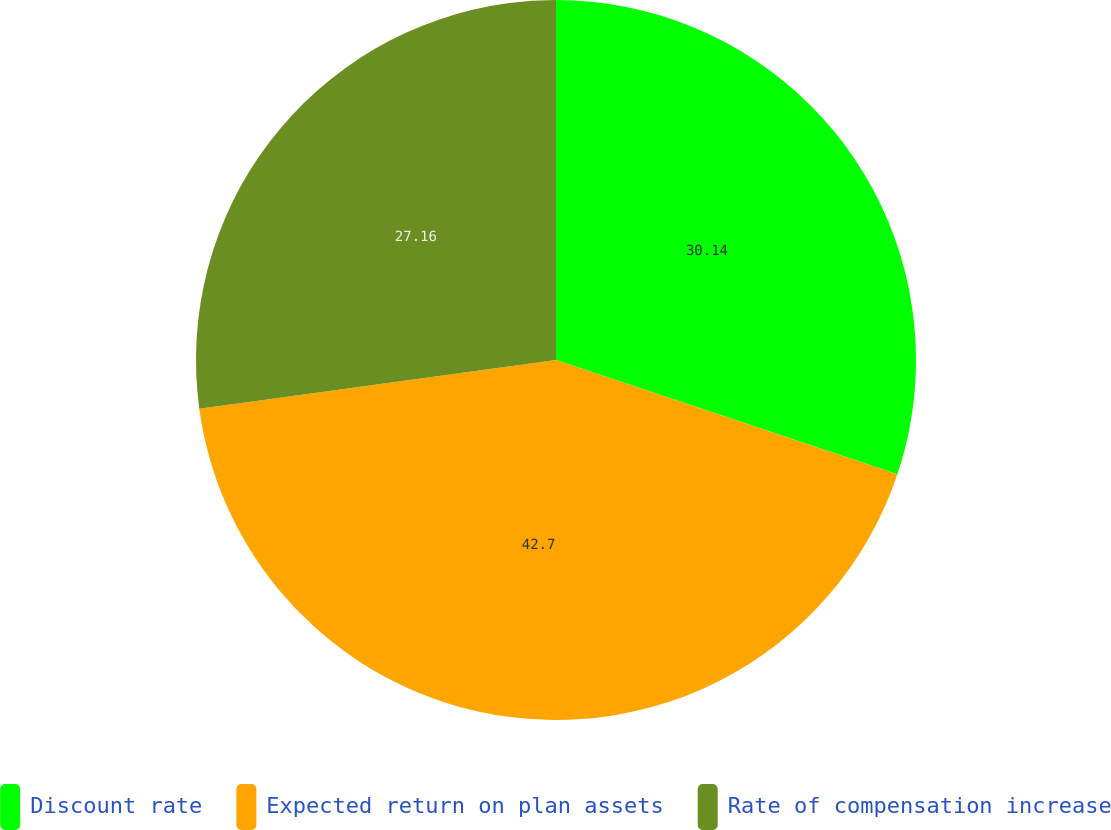Convert chart to OTSL. <chart><loc_0><loc_0><loc_500><loc_500><pie_chart><fcel>Discount rate<fcel>Expected return on plan assets<fcel>Rate of compensation increase<nl><fcel>30.14%<fcel>42.7%<fcel>27.16%<nl></chart> 